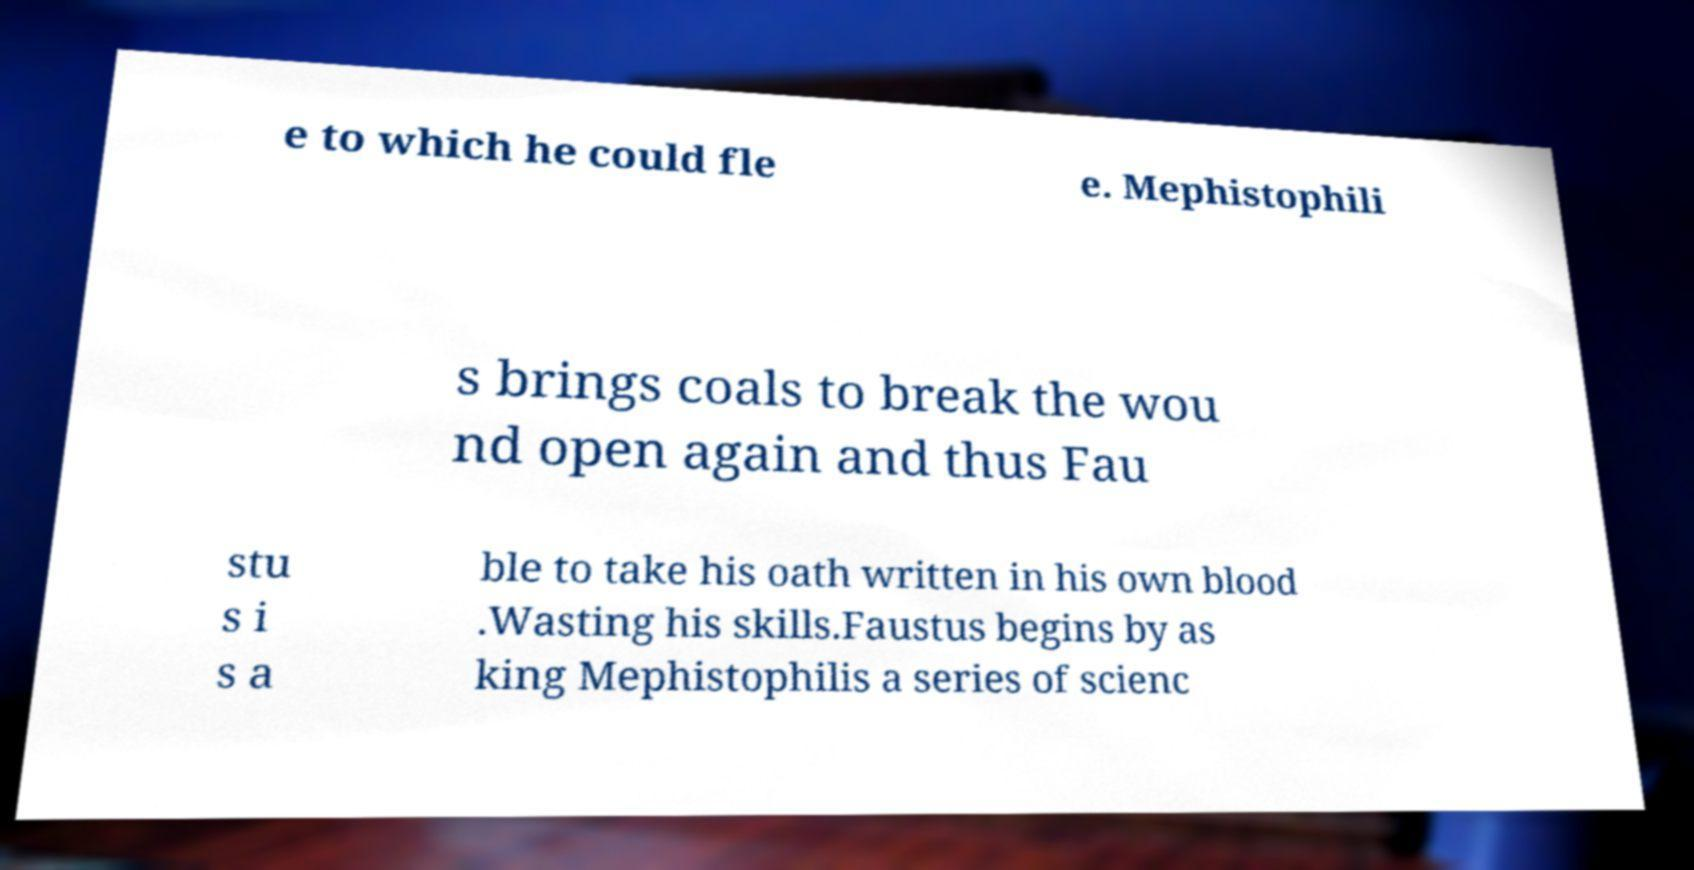Can you accurately transcribe the text from the provided image for me? e to which he could fle e. Mephistophili s brings coals to break the wou nd open again and thus Fau stu s i s a ble to take his oath written in his own blood .Wasting his skills.Faustus begins by as king Mephistophilis a series of scienc 